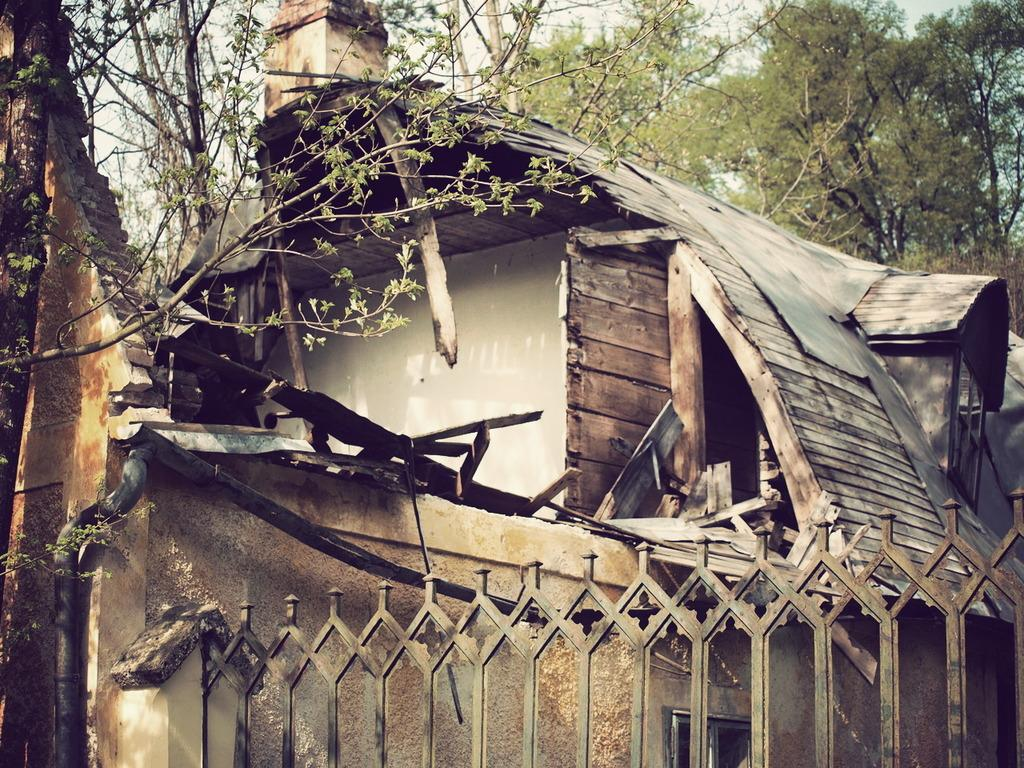What type of house is in the image? There is a wooden house in the image. What is in front of the house? There is a tall tree in front of the house. How is the tree in front of the house described? The tree is partially dried up. What can be seen behind the house? There are other trees visible behind the house. What type of tin is used to build the house in the image? The house in the image is made of wood, not tin. Can you see a giraffe behind the house in the image? There is no giraffe present in the image. 